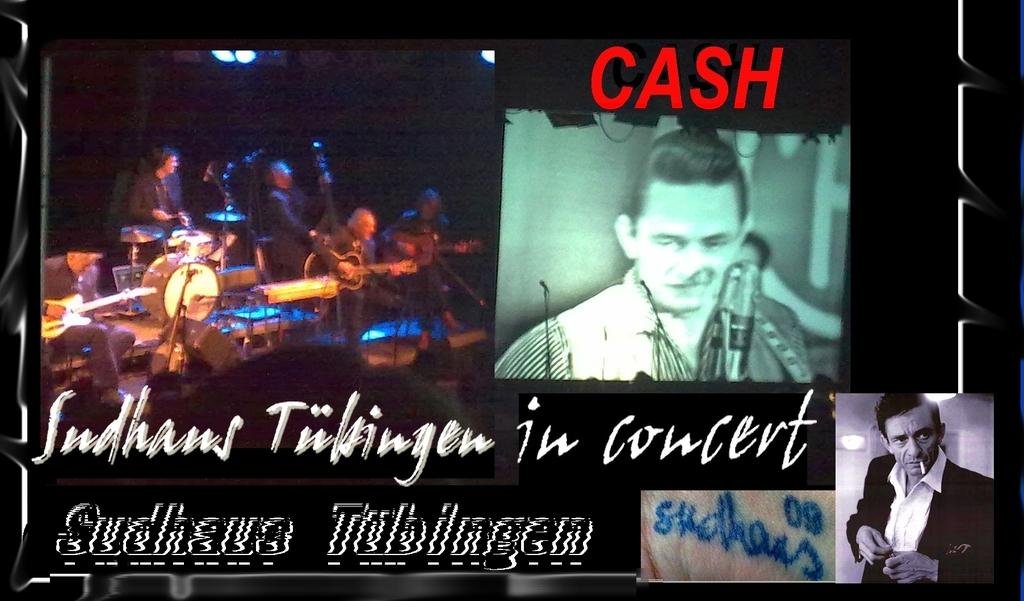What is the main feature of the image? There is a banner in the image. What is depicted on the banner? The banner contains musical drums and a mic. Are there any people in the image? Yes, there are people present in the image. What type of comb is being used by the people in the image? There is no comb visible in the image. Can you tell me the account number of the store featured on the banner? There is no store mentioned or depicted on the banner, so there is no account number to provide. 